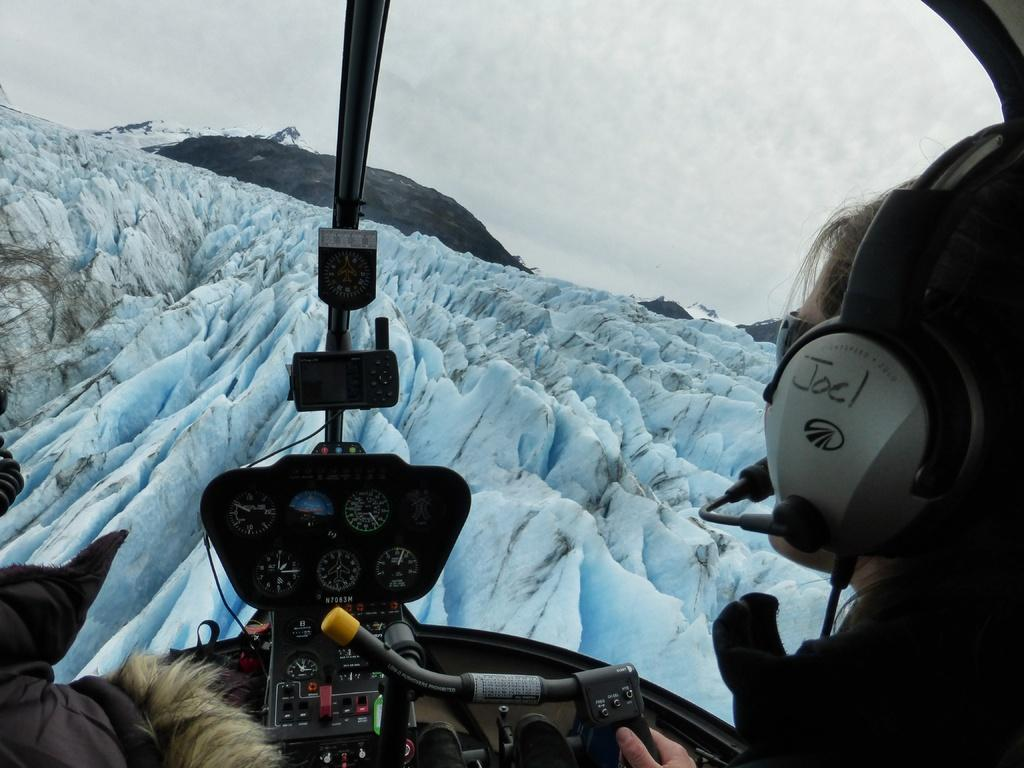What type of location is depicted in the image? The image shows the inside view of an airplane. What can be seen outside the airplane in the image? There is a mountain visible in the image. Are there any people present in the image? Yes, there is a person in the image. What is visible in the background of the image? The sky is visible in the background of the image. What type of animal is sitting next to the person in the image? There is no animal present in the image; it only shows the inside view of an airplane with a person and a mountain visible outside. 